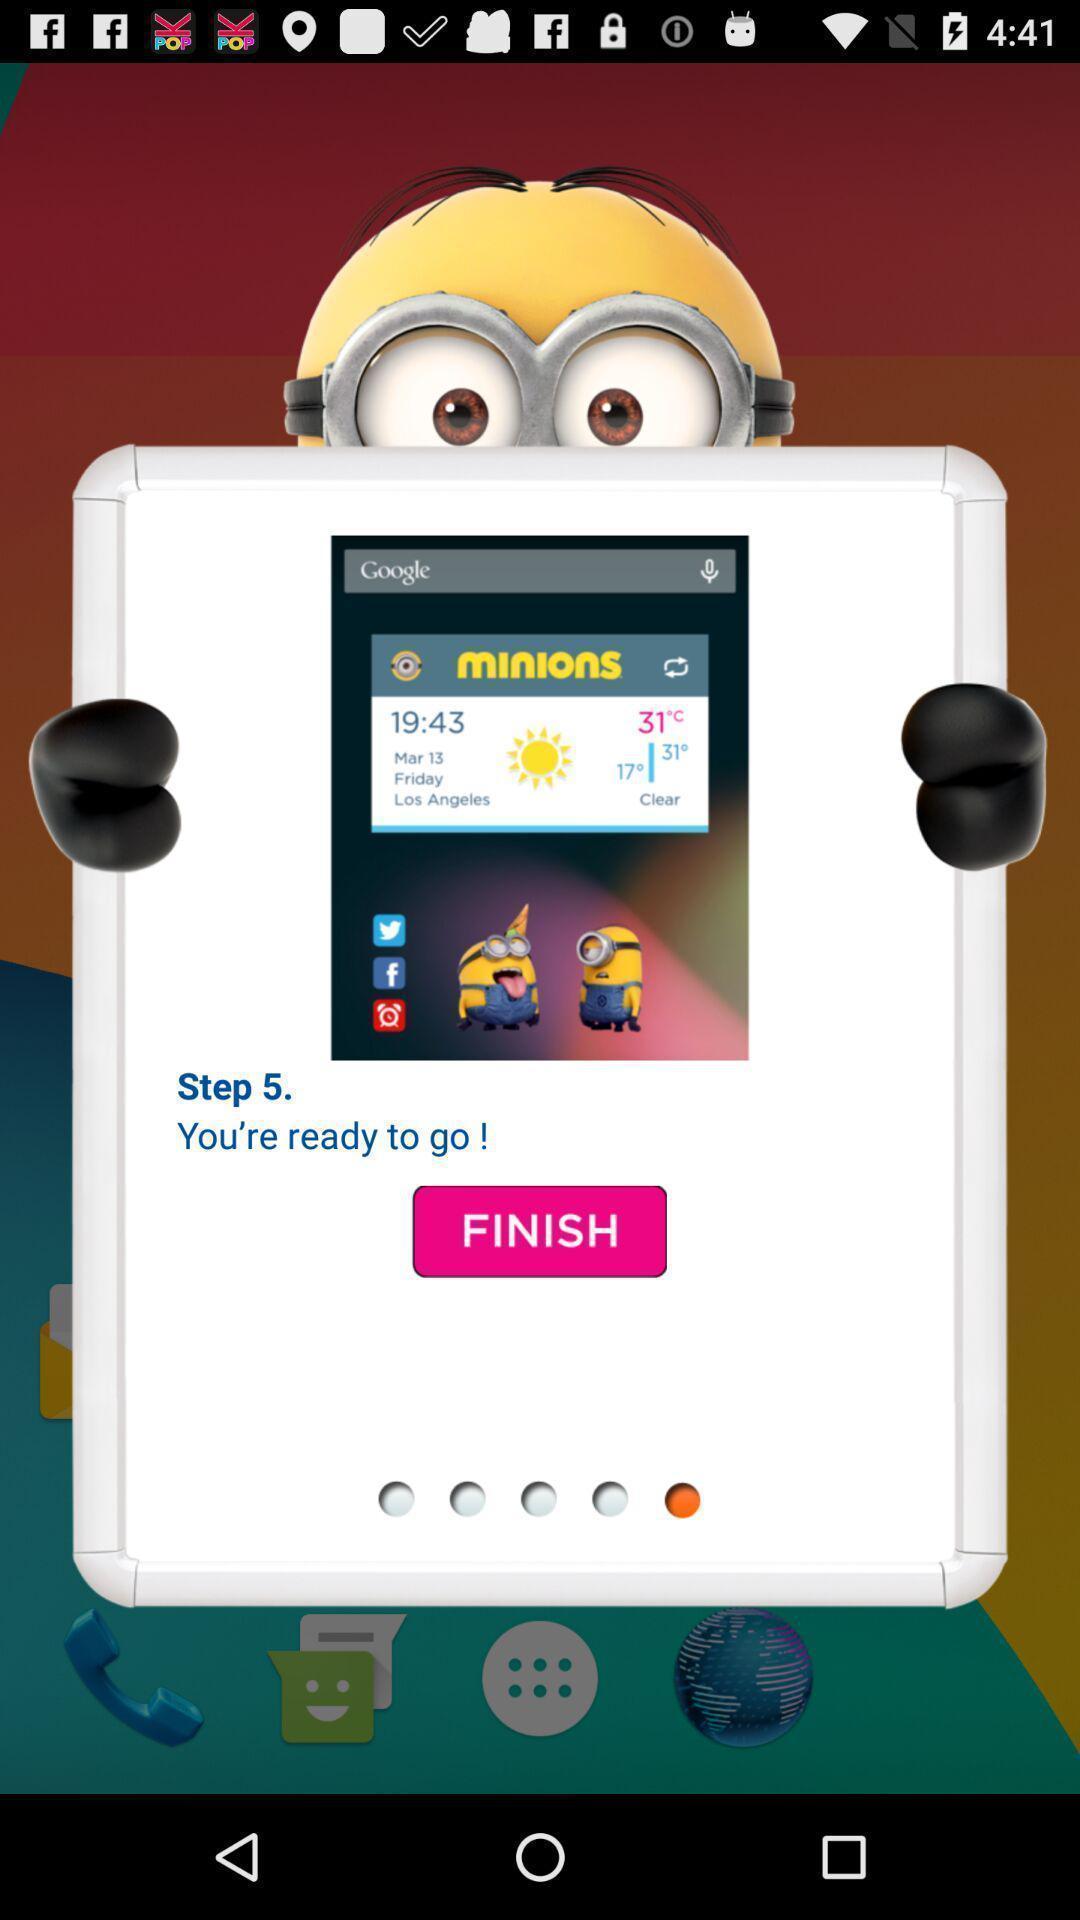What is the overall content of this screenshot? Setup page of a weather app. 